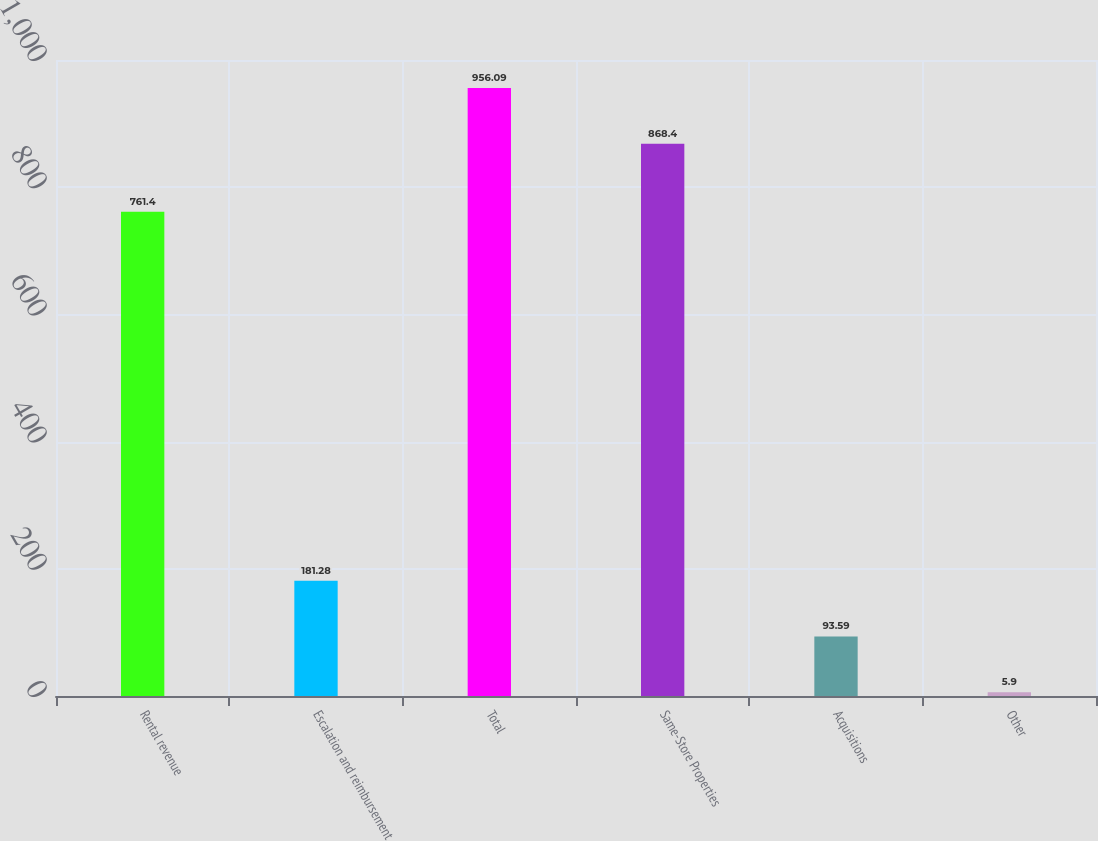Convert chart. <chart><loc_0><loc_0><loc_500><loc_500><bar_chart><fcel>Rental revenue<fcel>Escalation and reimbursement<fcel>Total<fcel>Same-Store Properties<fcel>Acquisitions<fcel>Other<nl><fcel>761.4<fcel>181.28<fcel>956.09<fcel>868.4<fcel>93.59<fcel>5.9<nl></chart> 